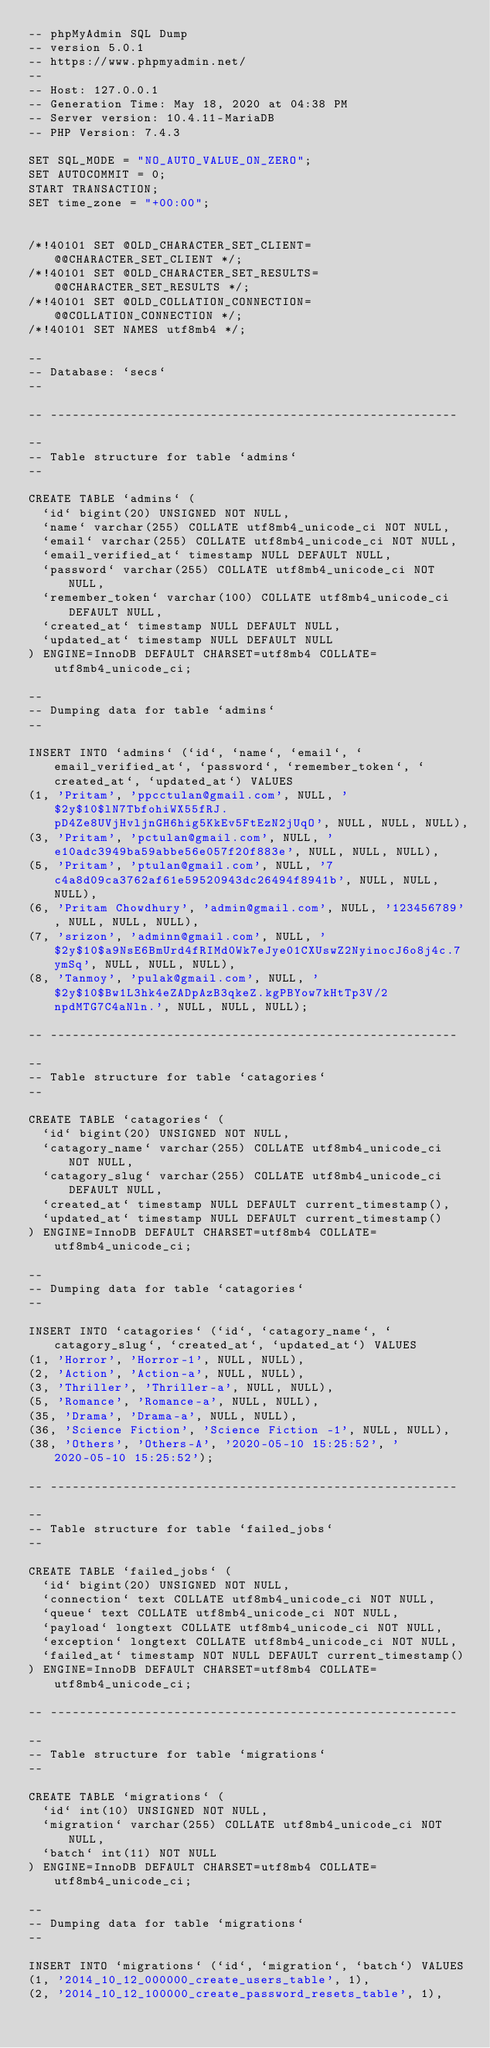Convert code to text. <code><loc_0><loc_0><loc_500><loc_500><_SQL_>-- phpMyAdmin SQL Dump
-- version 5.0.1
-- https://www.phpmyadmin.net/
--
-- Host: 127.0.0.1
-- Generation Time: May 18, 2020 at 04:38 PM
-- Server version: 10.4.11-MariaDB
-- PHP Version: 7.4.3

SET SQL_MODE = "NO_AUTO_VALUE_ON_ZERO";
SET AUTOCOMMIT = 0;
START TRANSACTION;
SET time_zone = "+00:00";


/*!40101 SET @OLD_CHARACTER_SET_CLIENT=@@CHARACTER_SET_CLIENT */;
/*!40101 SET @OLD_CHARACTER_SET_RESULTS=@@CHARACTER_SET_RESULTS */;
/*!40101 SET @OLD_COLLATION_CONNECTION=@@COLLATION_CONNECTION */;
/*!40101 SET NAMES utf8mb4 */;

--
-- Database: `secs`
--

-- --------------------------------------------------------

--
-- Table structure for table `admins`
--

CREATE TABLE `admins` (
  `id` bigint(20) UNSIGNED NOT NULL,
  `name` varchar(255) COLLATE utf8mb4_unicode_ci NOT NULL,
  `email` varchar(255) COLLATE utf8mb4_unicode_ci NOT NULL,
  `email_verified_at` timestamp NULL DEFAULT NULL,
  `password` varchar(255) COLLATE utf8mb4_unicode_ci NOT NULL,
  `remember_token` varchar(100) COLLATE utf8mb4_unicode_ci DEFAULT NULL,
  `created_at` timestamp NULL DEFAULT NULL,
  `updated_at` timestamp NULL DEFAULT NULL
) ENGINE=InnoDB DEFAULT CHARSET=utf8mb4 COLLATE=utf8mb4_unicode_ci;

--
-- Dumping data for table `admins`
--

INSERT INTO `admins` (`id`, `name`, `email`, `email_verified_at`, `password`, `remember_token`, `created_at`, `updated_at`) VALUES
(1, 'Pritam', 'ppcctulan@gmail.com', NULL, '$2y$10$lN7TbfohiWX55fRJ.pD4Ze8UVjHvljnGH6hig5KkEv5FtEzN2jUqO', NULL, NULL, NULL),
(3, 'Pritam', 'pctulan@gmail.com', NULL, 'e10adc3949ba59abbe56e057f20f883e', NULL, NULL, NULL),
(5, 'Pritam', 'ptulan@gmail.com', NULL, '7c4a8d09ca3762af61e59520943dc26494f8941b', NULL, NULL, NULL),
(6, 'Pritam Chowdhury', 'admin@gmail.com', NULL, '123456789', NULL, NULL, NULL),
(7, 'srizon', 'adminn@gmail.com', NULL, '$2y$10$a9NsE6BmUrd4fRIMd0Wk7eJye01CXUswZ2NyinocJ6o8j4c.7ymSq', NULL, NULL, NULL),
(8, 'Tanmoy', 'pulak@gmail.com', NULL, '$2y$10$Bw1L3hk4eZADpAzB3qkeZ.kgPBYow7kHtTp3V/2npdMTG7C4aNln.', NULL, NULL, NULL);

-- --------------------------------------------------------

--
-- Table structure for table `catagories`
--

CREATE TABLE `catagories` (
  `id` bigint(20) UNSIGNED NOT NULL,
  `catagory_name` varchar(255) COLLATE utf8mb4_unicode_ci NOT NULL,
  `catagory_slug` varchar(255) COLLATE utf8mb4_unicode_ci DEFAULT NULL,
  `created_at` timestamp NULL DEFAULT current_timestamp(),
  `updated_at` timestamp NULL DEFAULT current_timestamp()
) ENGINE=InnoDB DEFAULT CHARSET=utf8mb4 COLLATE=utf8mb4_unicode_ci;

--
-- Dumping data for table `catagories`
--

INSERT INTO `catagories` (`id`, `catagory_name`, `catagory_slug`, `created_at`, `updated_at`) VALUES
(1, 'Horror', 'Horror-1', NULL, NULL),
(2, 'Action', 'Action-a', NULL, NULL),
(3, 'Thriller', 'Thriller-a', NULL, NULL),
(5, 'Romance', 'Romance-a', NULL, NULL),
(35, 'Drama', 'Drama-a', NULL, NULL),
(36, 'Science Fiction', 'Science Fiction -1', NULL, NULL),
(38, 'Others', 'Others-A', '2020-05-10 15:25:52', '2020-05-10 15:25:52');

-- --------------------------------------------------------

--
-- Table structure for table `failed_jobs`
--

CREATE TABLE `failed_jobs` (
  `id` bigint(20) UNSIGNED NOT NULL,
  `connection` text COLLATE utf8mb4_unicode_ci NOT NULL,
  `queue` text COLLATE utf8mb4_unicode_ci NOT NULL,
  `payload` longtext COLLATE utf8mb4_unicode_ci NOT NULL,
  `exception` longtext COLLATE utf8mb4_unicode_ci NOT NULL,
  `failed_at` timestamp NOT NULL DEFAULT current_timestamp()
) ENGINE=InnoDB DEFAULT CHARSET=utf8mb4 COLLATE=utf8mb4_unicode_ci;

-- --------------------------------------------------------

--
-- Table structure for table `migrations`
--

CREATE TABLE `migrations` (
  `id` int(10) UNSIGNED NOT NULL,
  `migration` varchar(255) COLLATE utf8mb4_unicode_ci NOT NULL,
  `batch` int(11) NOT NULL
) ENGINE=InnoDB DEFAULT CHARSET=utf8mb4 COLLATE=utf8mb4_unicode_ci;

--
-- Dumping data for table `migrations`
--

INSERT INTO `migrations` (`id`, `migration`, `batch`) VALUES
(1, '2014_10_12_000000_create_users_table', 1),
(2, '2014_10_12_100000_create_password_resets_table', 1),</code> 